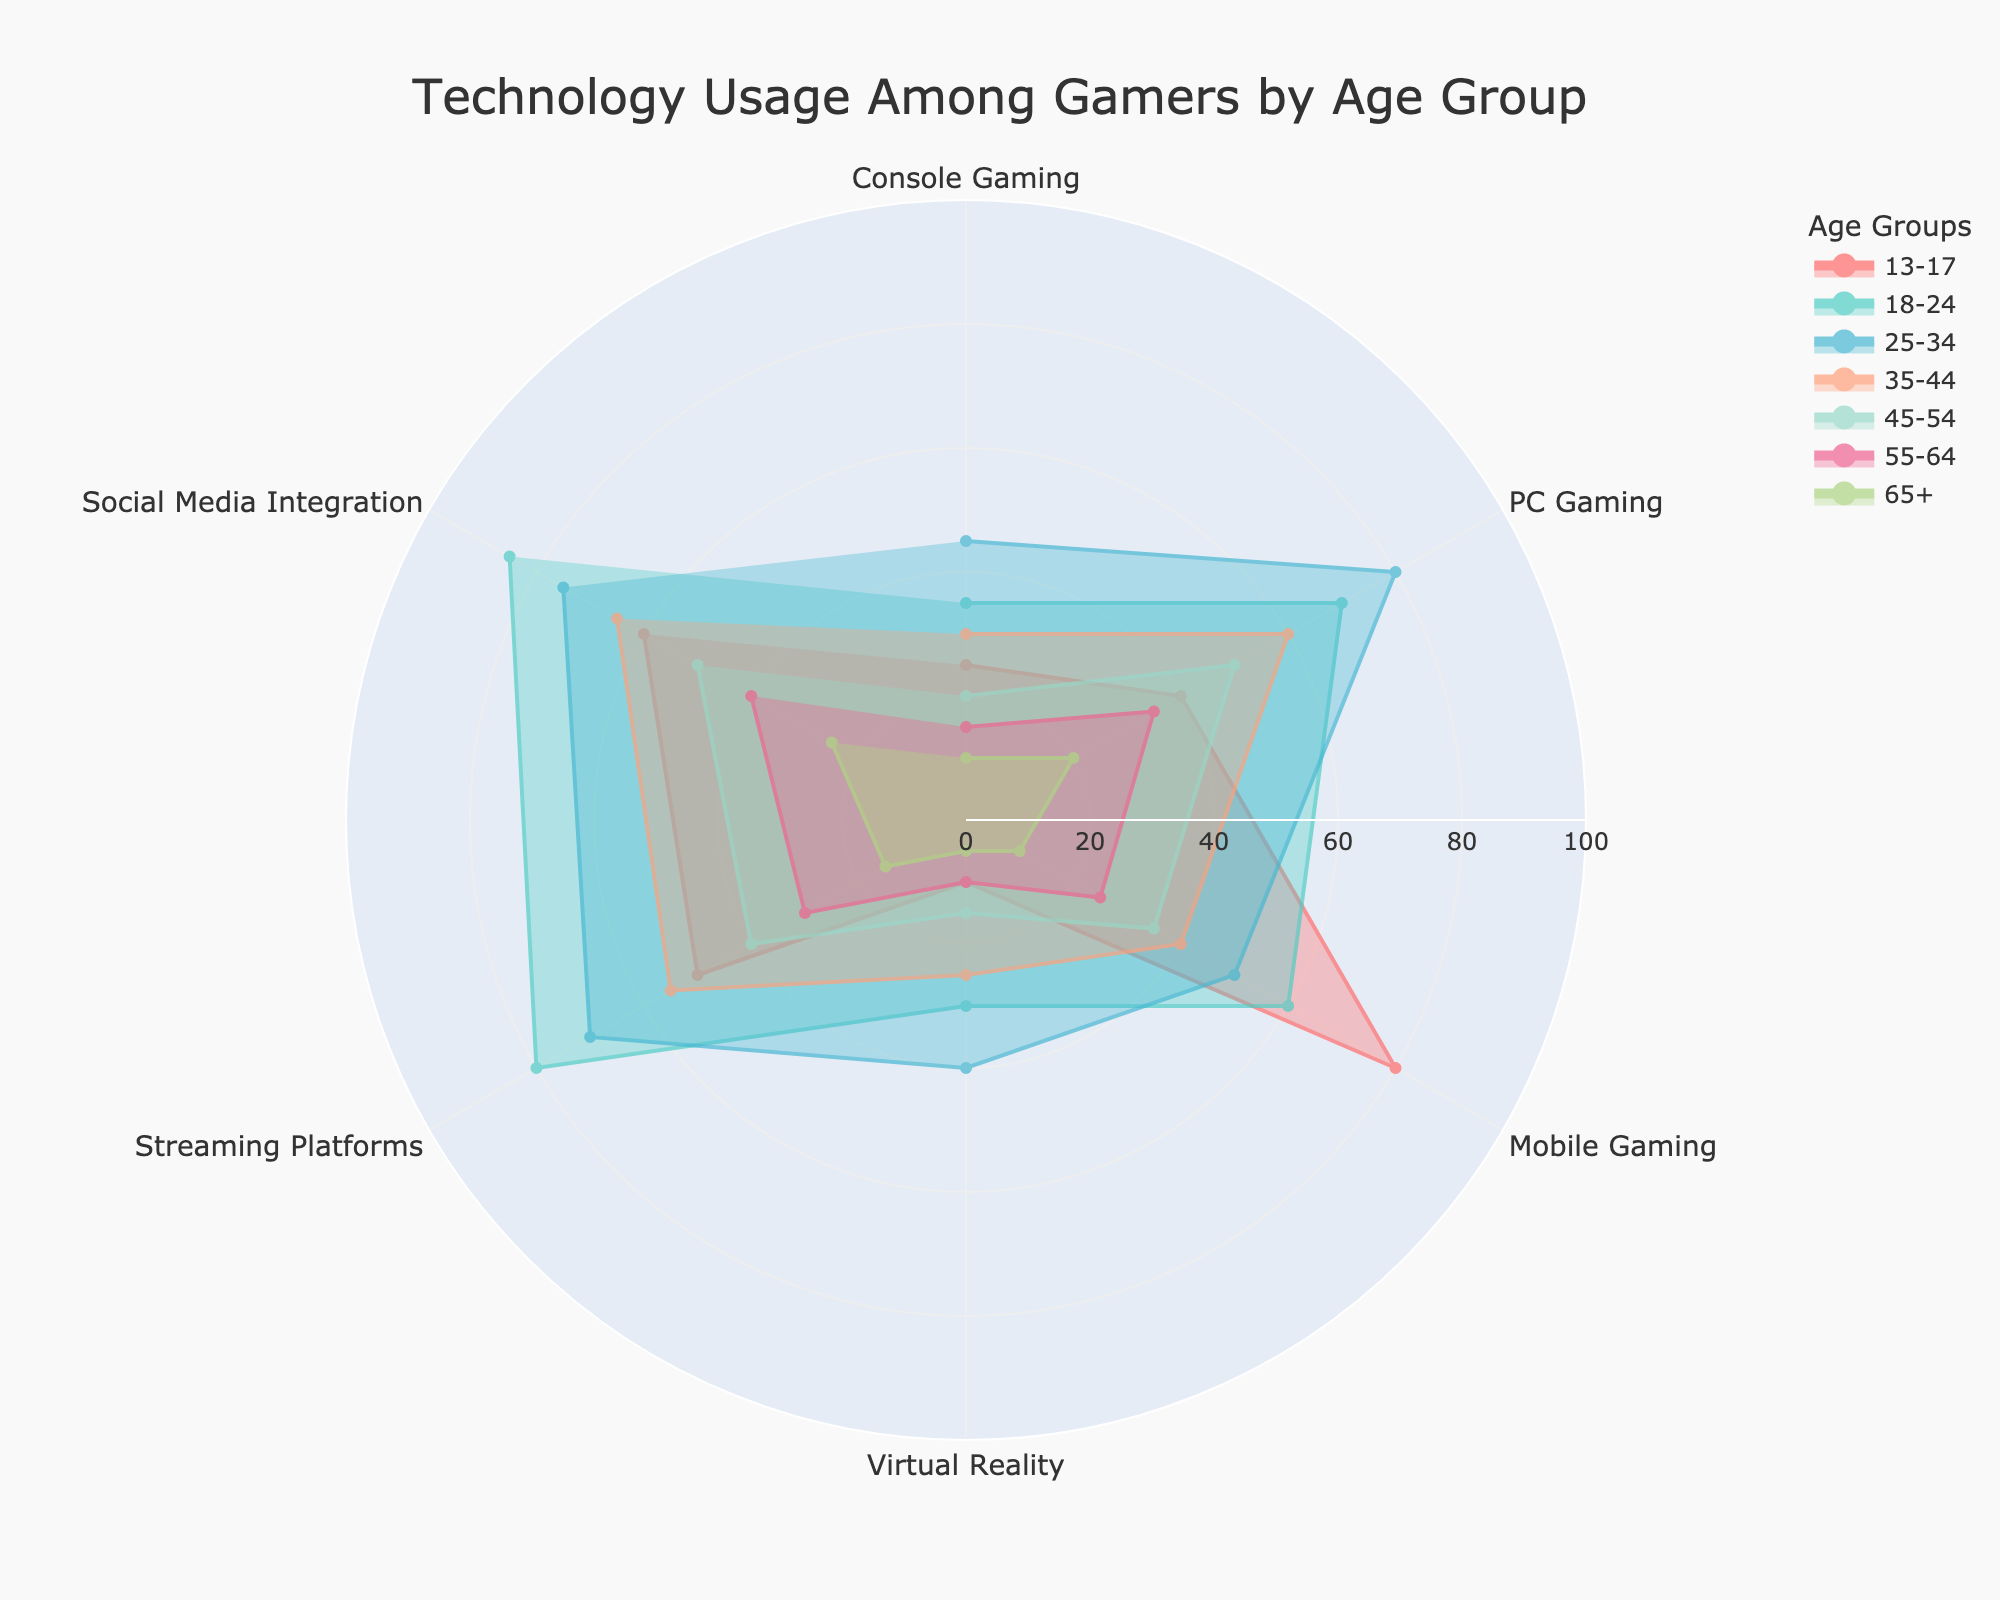what is the most popular technology among the 18-24 age group? Look at the section of the polar area chart that represents the 18-24 age group and find the category with the highest value. This is determined by the length of the corresponding section. The category with the highest value for the 18-24 age group is Streaming Platforms.
Answer: Streaming Platforms Which age group has the highest PC gaming usage? Check each age group's value for PC gaming on the chart and identify which one has the highest. The highest value for PC gaming usage belongs to the 25-34 age group.
Answer: 25-34 Which two age groups have the smallest difference in mobile gaming usage? Examine each age group's mobile gaming usage values and calculate the differences between their values. The 35-44 age group has 40 and the 45-54 age group has 35, and 40 - 35 = 5, which is the smallest difference.
Answer: 35-44 and 45-54 What is the average social media integration usage among the age groups 35-44 and 55-64? Add the social media integration values for the 35-44 and 55-64 age groups (65 and 40, respectively), and then divide by 2. \( (65 + 40) / 2 = 52.5 \).
Answer: 52.5 If you compare console gaming usage and VR usage among the 45-54 age group, which is higher and by how much? Use the values for console gaming and VR usage in the 45-54 age group (20 and 15, respectively). Combine the comparison and subtraction steps: \( 20 - 15 = 5 \), console gaming usage is higher by 5.
Answer: Console gaming by 5 Which age group shows the most balanced usage across all technology categories? Determine the total spread of values across all categories for each age group. The more balanced group will have a narrower range (difference between the smallest and largest values). The 55-64 age group has values of 15, 35, 25, 10, 30, and 40. The range, \(40 - 10 = 30\), is the smallest across age groups.
Answer: 55-64 What is the difference in streaming platform usage between the 13-17 and 65+ age groups? Compare the streaming platforms usage values for the 13-17 and 65+ age groups (50 and 15, respectively), and calculate the difference: \( 50 - 15 = 35 \).
Answer: 35 Which age group exhibits the highest usage of social media integration? Review the chart for the social media integration category and identify which age group has the longest section. The 18-24 age group shows the highest value of 85.
Answer: 18-24 For the age group 25-34, what is the sum of their console gaming and virtual reality usage? Add the values for console gaming and virtual reality usage for the 25-34 age group (45 and 40, respectively): \( 45 + 40 = 85 \).
Answer: 85 